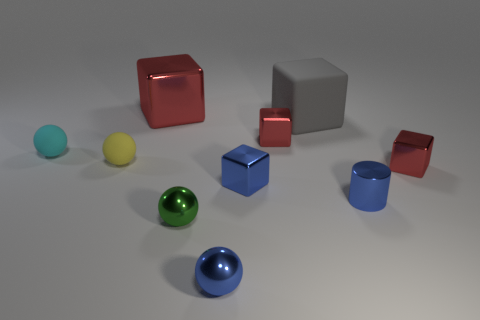How many red blocks must be subtracted to get 1 red blocks? 2 Subtract all brown cylinders. How many red blocks are left? 3 Subtract all blue blocks. How many blocks are left? 4 Subtract all large shiny cubes. How many cubes are left? 4 Subtract all cyan cubes. Subtract all gray balls. How many cubes are left? 5 Subtract all spheres. How many objects are left? 6 Subtract all large purple cubes. Subtract all small blue balls. How many objects are left? 9 Add 5 cyan things. How many cyan things are left? 6 Add 7 tiny blue metal cubes. How many tiny blue metal cubes exist? 8 Subtract 0 green cylinders. How many objects are left? 10 